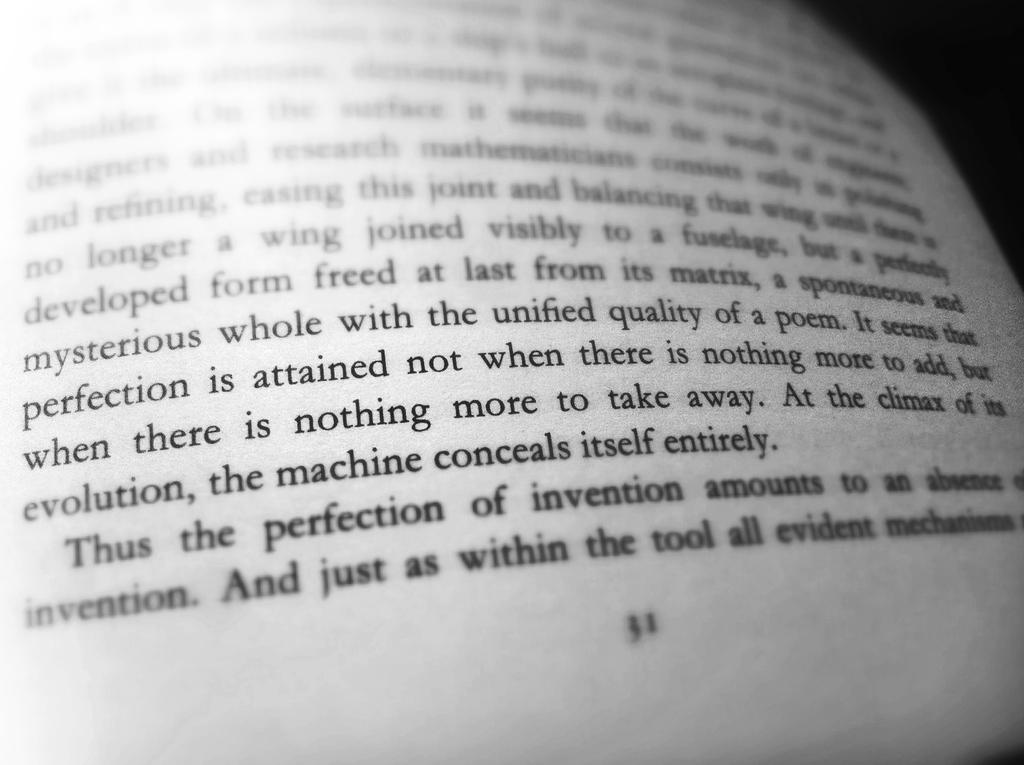<image>
Create a compact narrative representing the image presented. A passage in a book talking about attaining perfection. 